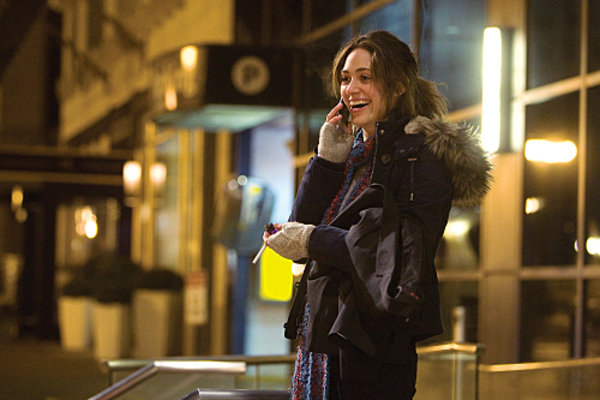What might be the subject of the woman's conversation that makes her smile so pleasantly? While it's impossible to know the exact details of her conversation, her joyful expression and relaxed posture might suggest she's sharing a delightful or amusing story with someone familiar, possibly catching up with a friend or discussing exciting personal news. 